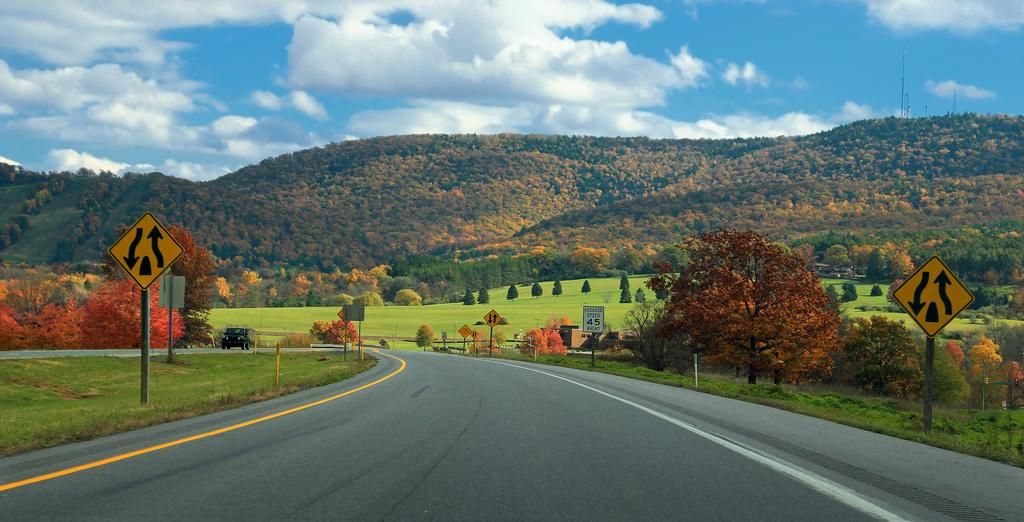What can be seen on the sign boards in the image? The content of the sign boards cannot be determined from the image. What type of vehicle is on the road in the image? The specific type of vehicle cannot be determined from the image. What type of vegetation is visible in the image? There is grass visible in the image. What can be seen in the background of the image? There are trees, hills, and the sky visible in the background of the image. What type of texture does the approval have in the image? There is no mention of approval or texture in the image. How much tax is being collected from the vehicle in the image? There is no indication of tax collection in the image. 